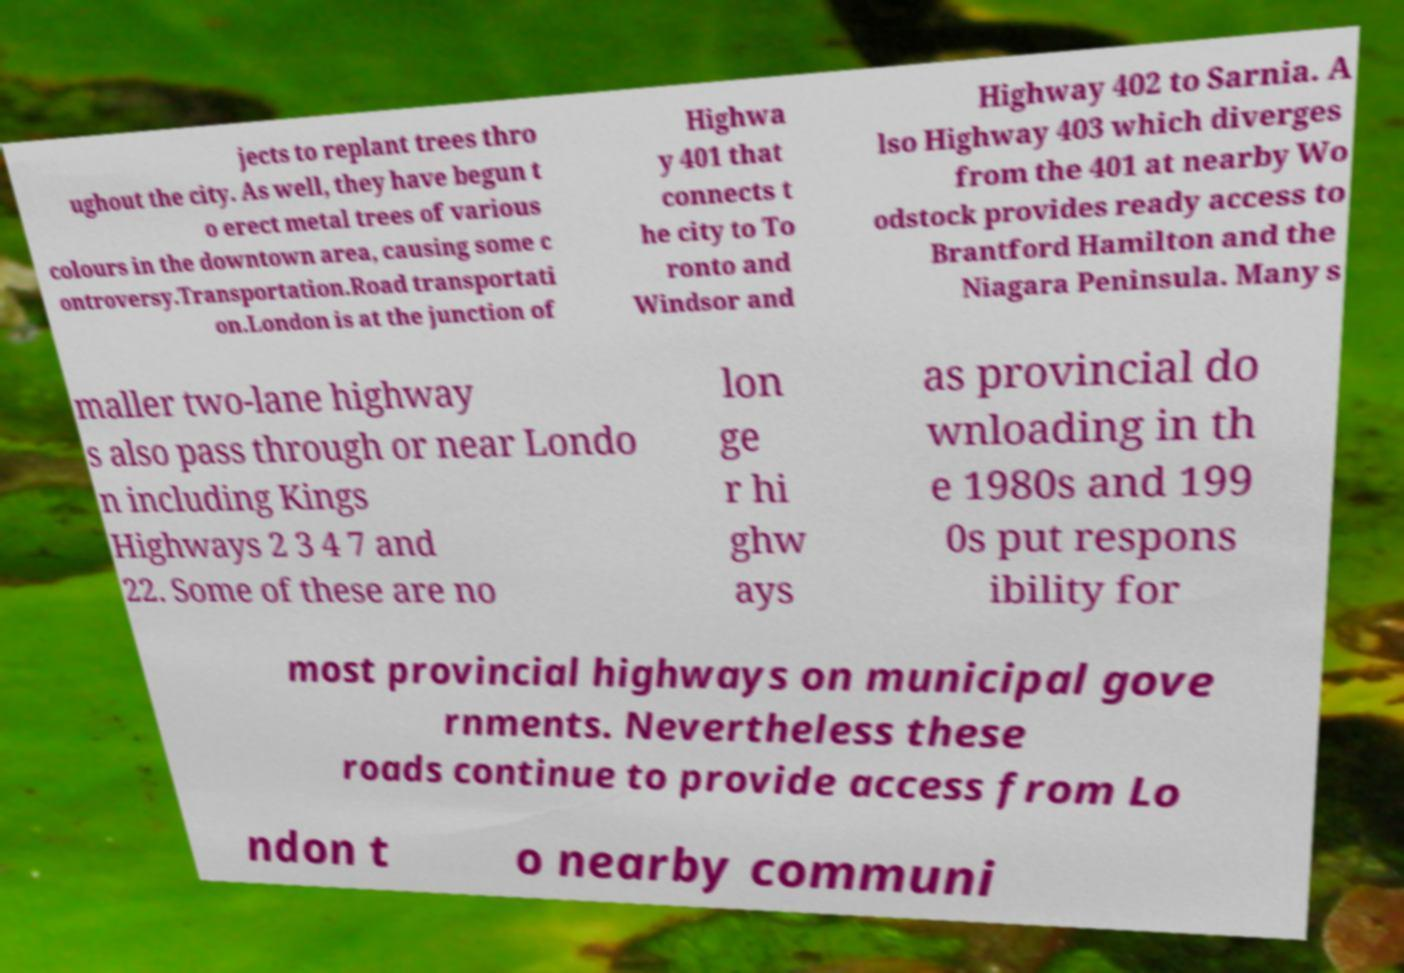Please read and relay the text visible in this image. What does it say? jects to replant trees thro ughout the city. As well, they have begun t o erect metal trees of various colours in the downtown area, causing some c ontroversy.Transportation.Road transportati on.London is at the junction of Highwa y 401 that connects t he city to To ronto and Windsor and Highway 402 to Sarnia. A lso Highway 403 which diverges from the 401 at nearby Wo odstock provides ready access to Brantford Hamilton and the Niagara Peninsula. Many s maller two-lane highway s also pass through or near Londo n including Kings Highways 2 3 4 7 and 22. Some of these are no lon ge r hi ghw ays as provincial do wnloading in th e 1980s and 199 0s put respons ibility for most provincial highways on municipal gove rnments. Nevertheless these roads continue to provide access from Lo ndon t o nearby communi 